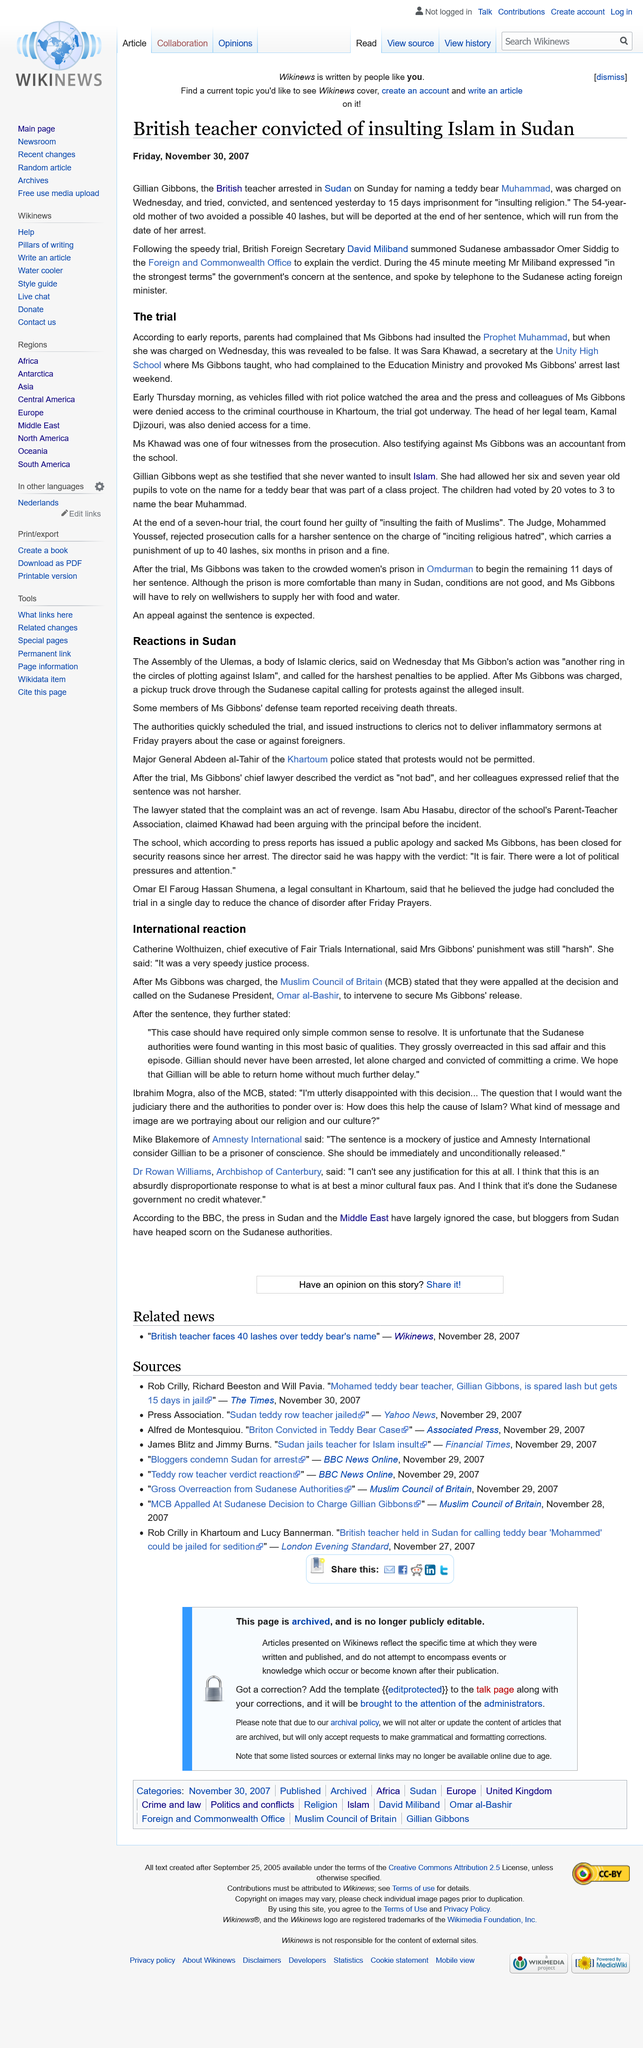Mention a couple of crucial points in this snapshot. The article was published on Friday, November 30, 2007. Ms. Gibbons was charged and sentenced in the trial. A British teacher was convicted of insulting Islam in Sudan. Protests are not permitted in Kartoum in response to the sentencing. Mr. Miliband expressed the government's concern during a 45-minute meeting regarding the severity of the sentence. 